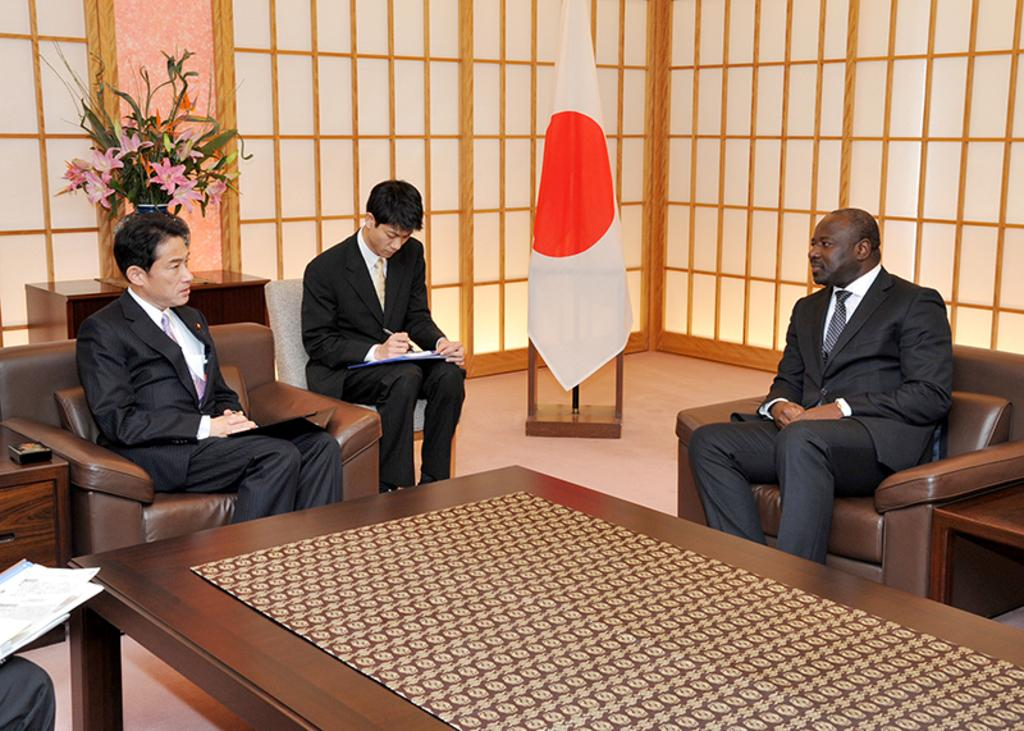How many people are in the image? There are three people in the image. What are the people doing in the image? The people are sitting on chairs. What are the people wearing in the image? The people are wearing black suits. What can be seen besides the people in the image? There is a flag and a flower pot on a table in the image. Where are the worms crawling in the image? There are no worms present in the image. How many houses can be seen in the image? There are no houses present in the image. 